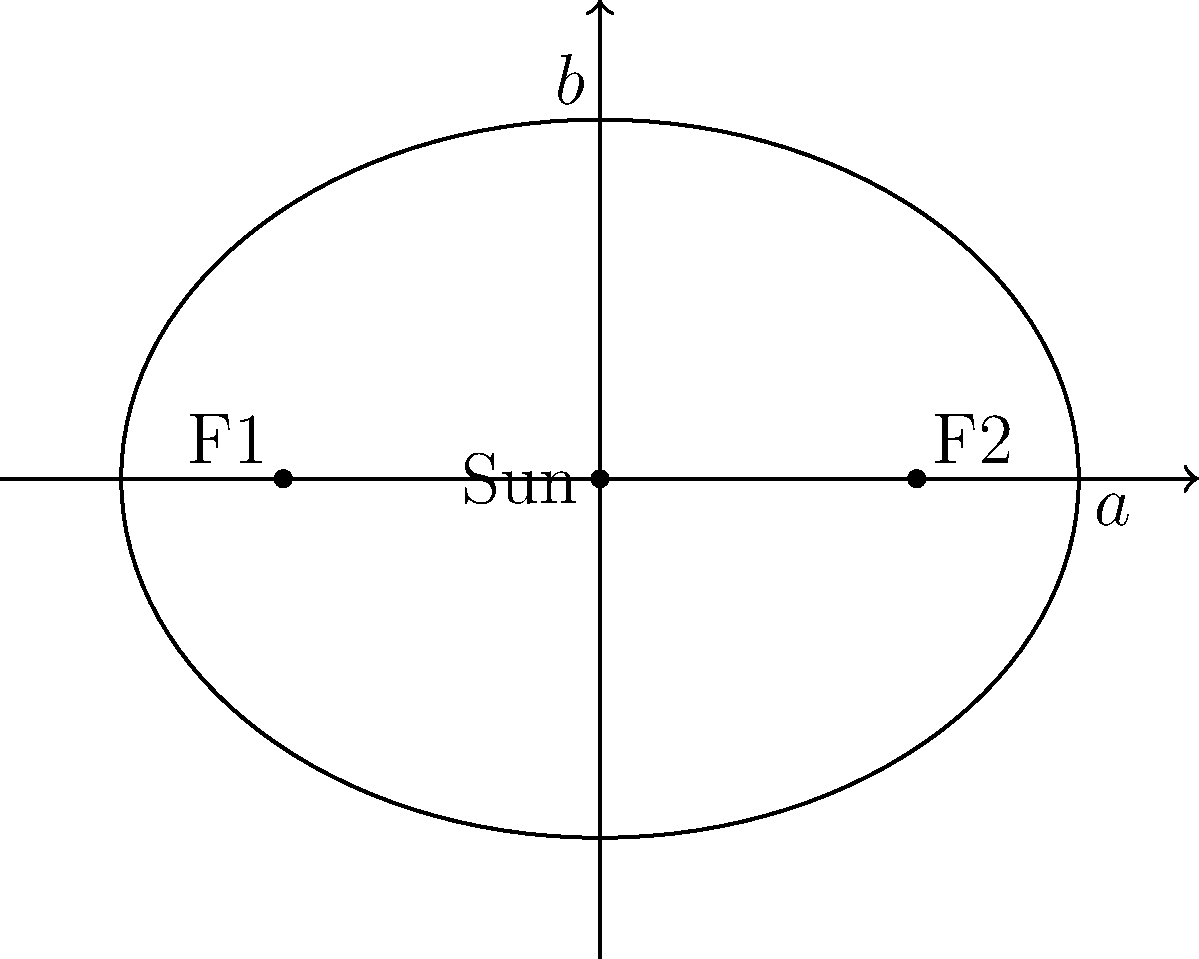In this elliptical orbit diagram, reminiscent of the cosmic dance we used to imagine while listening to Baccara's "Yes Sir, I Can Boogie," what is the eccentricity of the orbit? Express your answer in terms of $a$ and $b$. Let's approach this step-by-step, just like we used to break down Baccara's lyrics:

1) The eccentricity ($e$) of an ellipse is defined as the ratio of the distance between the foci to the length of the major axis. It can be calculated using the formula:

   $$e = \sqrt{1 - \frac{b^2}{a^2}}$$

   Where $a$ is the semi-major axis and $b$ is the semi-minor axis.

2) In the diagram, we can see that $a$ is the longer semi-axis (horizontal) and $b$ is the shorter semi-axis (vertical).

3) We don't need to know the exact values of $a$ and $b$. We can express the eccentricity in terms of these variables.

4) Substituting these into our formula:

   $$e = \sqrt{1 - \frac{b^2}{a^2}}$$

5) This expression can't be simplified further without knowing the specific values of $a$ and $b$.

Just as Baccara's music brought celestial harmony to our ears, this formula brings harmony to the elliptical dance of planets around the Sun.
Answer: $$\sqrt{1 - \frac{b^2}{a^2}}$$ 